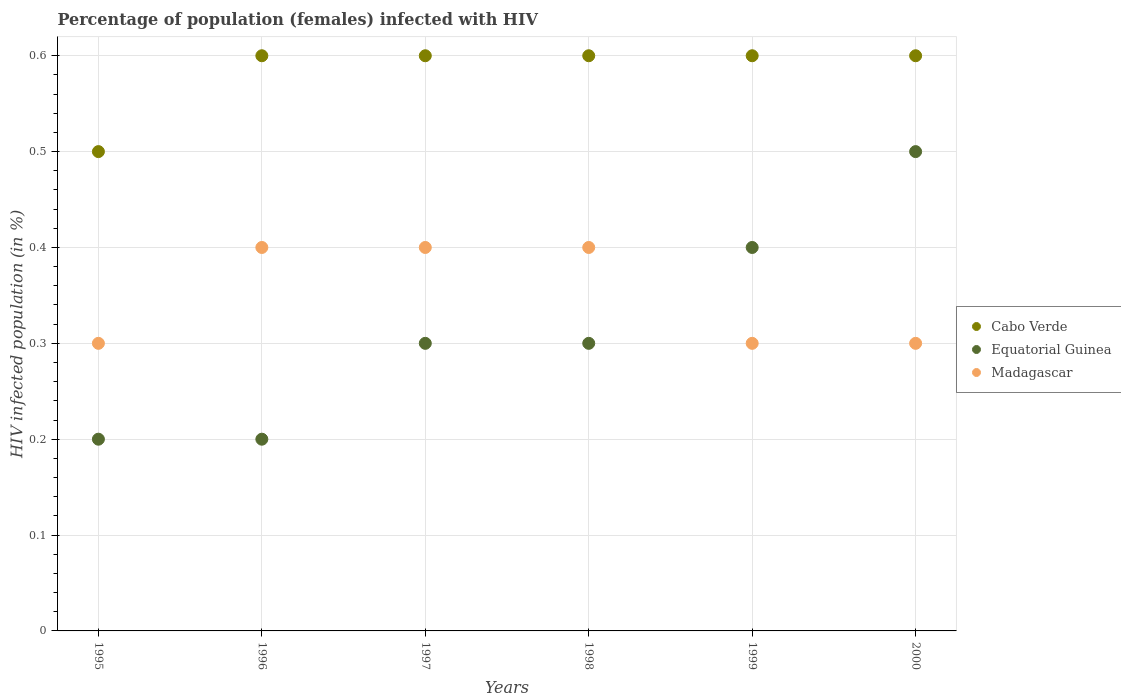Is the number of dotlines equal to the number of legend labels?
Offer a terse response. Yes. Across all years, what is the maximum percentage of HIV infected female population in Madagascar?
Give a very brief answer. 0.4. Across all years, what is the minimum percentage of HIV infected female population in Cabo Verde?
Keep it short and to the point. 0.5. In which year was the percentage of HIV infected female population in Cabo Verde maximum?
Provide a succinct answer. 1996. What is the total percentage of HIV infected female population in Cabo Verde in the graph?
Ensure brevity in your answer.  3.5. What is the difference between the percentage of HIV infected female population in Cabo Verde in 1995 and the percentage of HIV infected female population in Equatorial Guinea in 2000?
Make the answer very short. 0. What is the average percentage of HIV infected female population in Cabo Verde per year?
Ensure brevity in your answer.  0.58. In how many years, is the percentage of HIV infected female population in Madagascar greater than 0.30000000000000004 %?
Keep it short and to the point. 3. What is the ratio of the percentage of HIV infected female population in Equatorial Guinea in 1997 to that in 1999?
Give a very brief answer. 0.75. Is the percentage of HIV infected female population in Cabo Verde in 1997 less than that in 1999?
Your answer should be compact. No. Is the difference between the percentage of HIV infected female population in Cabo Verde in 1995 and 1996 greater than the difference between the percentage of HIV infected female population in Equatorial Guinea in 1995 and 1996?
Make the answer very short. No. What is the difference between the highest and the second highest percentage of HIV infected female population in Equatorial Guinea?
Keep it short and to the point. 0.1. What is the difference between the highest and the lowest percentage of HIV infected female population in Madagascar?
Your response must be concise. 0.1. In how many years, is the percentage of HIV infected female population in Equatorial Guinea greater than the average percentage of HIV infected female population in Equatorial Guinea taken over all years?
Make the answer very short. 2. Does the percentage of HIV infected female population in Equatorial Guinea monotonically increase over the years?
Keep it short and to the point. No. Is the percentage of HIV infected female population in Madagascar strictly greater than the percentage of HIV infected female population in Cabo Verde over the years?
Your answer should be compact. No. How many dotlines are there?
Your answer should be compact. 3. Are the values on the major ticks of Y-axis written in scientific E-notation?
Offer a very short reply. No. Does the graph contain any zero values?
Your answer should be compact. No. Does the graph contain grids?
Offer a very short reply. Yes. Where does the legend appear in the graph?
Your answer should be compact. Center right. How are the legend labels stacked?
Provide a short and direct response. Vertical. What is the title of the graph?
Offer a terse response. Percentage of population (females) infected with HIV. What is the label or title of the Y-axis?
Give a very brief answer. HIV infected population (in %). What is the HIV infected population (in %) of Madagascar in 1996?
Ensure brevity in your answer.  0.4. What is the HIV infected population (in %) in Equatorial Guinea in 1997?
Give a very brief answer. 0.3. What is the HIV infected population (in %) of Madagascar in 1997?
Provide a succinct answer. 0.4. What is the HIV infected population (in %) of Equatorial Guinea in 1998?
Offer a very short reply. 0.3. What is the HIV infected population (in %) of Cabo Verde in 2000?
Make the answer very short. 0.6. What is the HIV infected population (in %) in Equatorial Guinea in 2000?
Provide a succinct answer. 0.5. Across all years, what is the maximum HIV infected population (in %) of Cabo Verde?
Your answer should be compact. 0.6. Across all years, what is the minimum HIV infected population (in %) of Cabo Verde?
Offer a terse response. 0.5. Across all years, what is the minimum HIV infected population (in %) in Equatorial Guinea?
Offer a terse response. 0.2. Across all years, what is the minimum HIV infected population (in %) of Madagascar?
Offer a terse response. 0.3. What is the total HIV infected population (in %) of Equatorial Guinea in the graph?
Make the answer very short. 1.9. What is the difference between the HIV infected population (in %) of Cabo Verde in 1995 and that in 1996?
Offer a terse response. -0.1. What is the difference between the HIV infected population (in %) of Madagascar in 1995 and that in 1997?
Keep it short and to the point. -0.1. What is the difference between the HIV infected population (in %) of Equatorial Guinea in 1995 and that in 1998?
Your answer should be compact. -0.1. What is the difference between the HIV infected population (in %) of Cabo Verde in 1995 and that in 1999?
Give a very brief answer. -0.1. What is the difference between the HIV infected population (in %) of Equatorial Guinea in 1995 and that in 1999?
Offer a very short reply. -0.2. What is the difference between the HIV infected population (in %) of Cabo Verde in 1995 and that in 2000?
Your response must be concise. -0.1. What is the difference between the HIV infected population (in %) in Madagascar in 1996 and that in 1997?
Make the answer very short. 0. What is the difference between the HIV infected population (in %) of Madagascar in 1996 and that in 1998?
Provide a short and direct response. 0. What is the difference between the HIV infected population (in %) in Cabo Verde in 1996 and that in 1999?
Give a very brief answer. 0. What is the difference between the HIV infected population (in %) of Cabo Verde in 1996 and that in 2000?
Give a very brief answer. 0. What is the difference between the HIV infected population (in %) of Equatorial Guinea in 1996 and that in 2000?
Offer a very short reply. -0.3. What is the difference between the HIV infected population (in %) of Cabo Verde in 1997 and that in 1999?
Provide a succinct answer. 0. What is the difference between the HIV infected population (in %) in Madagascar in 1997 and that in 1999?
Ensure brevity in your answer.  0.1. What is the difference between the HIV infected population (in %) in Cabo Verde in 1997 and that in 2000?
Offer a very short reply. 0. What is the difference between the HIV infected population (in %) in Madagascar in 1997 and that in 2000?
Make the answer very short. 0.1. What is the difference between the HIV infected population (in %) in Equatorial Guinea in 1998 and that in 1999?
Provide a succinct answer. -0.1. What is the difference between the HIV infected population (in %) of Madagascar in 1998 and that in 1999?
Make the answer very short. 0.1. What is the difference between the HIV infected population (in %) of Madagascar in 1998 and that in 2000?
Provide a short and direct response. 0.1. What is the difference between the HIV infected population (in %) in Cabo Verde in 1999 and that in 2000?
Offer a terse response. 0. What is the difference between the HIV infected population (in %) in Cabo Verde in 1995 and the HIV infected population (in %) in Madagascar in 1997?
Provide a succinct answer. 0.1. What is the difference between the HIV infected population (in %) in Equatorial Guinea in 1995 and the HIV infected population (in %) in Madagascar in 1997?
Your answer should be compact. -0.2. What is the difference between the HIV infected population (in %) in Cabo Verde in 1995 and the HIV infected population (in %) in Equatorial Guinea in 1998?
Offer a very short reply. 0.2. What is the difference between the HIV infected population (in %) in Cabo Verde in 1995 and the HIV infected population (in %) in Madagascar in 1998?
Make the answer very short. 0.1. What is the difference between the HIV infected population (in %) of Equatorial Guinea in 1995 and the HIV infected population (in %) of Madagascar in 1998?
Your answer should be very brief. -0.2. What is the difference between the HIV infected population (in %) of Equatorial Guinea in 1995 and the HIV infected population (in %) of Madagascar in 1999?
Offer a very short reply. -0.1. What is the difference between the HIV infected population (in %) of Cabo Verde in 1996 and the HIV infected population (in %) of Madagascar in 1997?
Ensure brevity in your answer.  0.2. What is the difference between the HIV infected population (in %) in Equatorial Guinea in 1996 and the HIV infected population (in %) in Madagascar in 1997?
Provide a short and direct response. -0.2. What is the difference between the HIV infected population (in %) of Cabo Verde in 1996 and the HIV infected population (in %) of Equatorial Guinea in 1998?
Give a very brief answer. 0.3. What is the difference between the HIV infected population (in %) in Cabo Verde in 1996 and the HIV infected population (in %) in Madagascar in 1998?
Provide a short and direct response. 0.2. What is the difference between the HIV infected population (in %) of Equatorial Guinea in 1996 and the HIV infected population (in %) of Madagascar in 1998?
Offer a terse response. -0.2. What is the difference between the HIV infected population (in %) of Cabo Verde in 1996 and the HIV infected population (in %) of Equatorial Guinea in 1999?
Provide a succinct answer. 0.2. What is the difference between the HIV infected population (in %) in Equatorial Guinea in 1996 and the HIV infected population (in %) in Madagascar in 1999?
Offer a terse response. -0.1. What is the difference between the HIV infected population (in %) in Equatorial Guinea in 1996 and the HIV infected population (in %) in Madagascar in 2000?
Offer a very short reply. -0.1. What is the difference between the HIV infected population (in %) in Cabo Verde in 1997 and the HIV infected population (in %) in Equatorial Guinea in 1999?
Keep it short and to the point. 0.2. What is the difference between the HIV infected population (in %) of Equatorial Guinea in 1997 and the HIV infected population (in %) of Madagascar in 1999?
Ensure brevity in your answer.  0. What is the difference between the HIV infected population (in %) of Equatorial Guinea in 1997 and the HIV infected population (in %) of Madagascar in 2000?
Your answer should be very brief. 0. What is the difference between the HIV infected population (in %) of Cabo Verde in 1998 and the HIV infected population (in %) of Equatorial Guinea in 1999?
Keep it short and to the point. 0.2. What is the difference between the HIV infected population (in %) in Cabo Verde in 1998 and the HIV infected population (in %) in Madagascar in 1999?
Give a very brief answer. 0.3. What is the difference between the HIV infected population (in %) in Cabo Verde in 1999 and the HIV infected population (in %) in Equatorial Guinea in 2000?
Your answer should be very brief. 0.1. What is the difference between the HIV infected population (in %) of Equatorial Guinea in 1999 and the HIV infected population (in %) of Madagascar in 2000?
Offer a very short reply. 0.1. What is the average HIV infected population (in %) in Cabo Verde per year?
Your answer should be compact. 0.58. What is the average HIV infected population (in %) in Equatorial Guinea per year?
Keep it short and to the point. 0.32. In the year 1995, what is the difference between the HIV infected population (in %) in Equatorial Guinea and HIV infected population (in %) in Madagascar?
Offer a very short reply. -0.1. In the year 1996, what is the difference between the HIV infected population (in %) in Cabo Verde and HIV infected population (in %) in Equatorial Guinea?
Your answer should be compact. 0.4. In the year 1996, what is the difference between the HIV infected population (in %) in Cabo Verde and HIV infected population (in %) in Madagascar?
Provide a short and direct response. 0.2. In the year 1997, what is the difference between the HIV infected population (in %) of Cabo Verde and HIV infected population (in %) of Equatorial Guinea?
Offer a very short reply. 0.3. In the year 1997, what is the difference between the HIV infected population (in %) of Equatorial Guinea and HIV infected population (in %) of Madagascar?
Keep it short and to the point. -0.1. In the year 1998, what is the difference between the HIV infected population (in %) in Equatorial Guinea and HIV infected population (in %) in Madagascar?
Make the answer very short. -0.1. In the year 1999, what is the difference between the HIV infected population (in %) of Cabo Verde and HIV infected population (in %) of Equatorial Guinea?
Keep it short and to the point. 0.2. In the year 1999, what is the difference between the HIV infected population (in %) of Cabo Verde and HIV infected population (in %) of Madagascar?
Your answer should be very brief. 0.3. In the year 1999, what is the difference between the HIV infected population (in %) of Equatorial Guinea and HIV infected population (in %) of Madagascar?
Keep it short and to the point. 0.1. What is the ratio of the HIV infected population (in %) in Equatorial Guinea in 1995 to that in 1997?
Your response must be concise. 0.67. What is the ratio of the HIV infected population (in %) in Madagascar in 1995 to that in 1999?
Provide a succinct answer. 1. What is the ratio of the HIV infected population (in %) in Equatorial Guinea in 1995 to that in 2000?
Offer a very short reply. 0.4. What is the ratio of the HIV infected population (in %) in Equatorial Guinea in 1996 to that in 1997?
Keep it short and to the point. 0.67. What is the ratio of the HIV infected population (in %) in Cabo Verde in 1996 to that in 1998?
Make the answer very short. 1. What is the ratio of the HIV infected population (in %) of Cabo Verde in 1996 to that in 1999?
Give a very brief answer. 1. What is the ratio of the HIV infected population (in %) of Cabo Verde in 1996 to that in 2000?
Ensure brevity in your answer.  1. What is the ratio of the HIV infected population (in %) of Madagascar in 1996 to that in 2000?
Offer a terse response. 1.33. What is the ratio of the HIV infected population (in %) of Cabo Verde in 1997 to that in 1998?
Keep it short and to the point. 1. What is the ratio of the HIV infected population (in %) in Equatorial Guinea in 1997 to that in 1999?
Ensure brevity in your answer.  0.75. What is the ratio of the HIV infected population (in %) of Madagascar in 1997 to that in 1999?
Give a very brief answer. 1.33. What is the ratio of the HIV infected population (in %) in Equatorial Guinea in 1997 to that in 2000?
Your response must be concise. 0.6. What is the ratio of the HIV infected population (in %) of Madagascar in 1997 to that in 2000?
Ensure brevity in your answer.  1.33. What is the ratio of the HIV infected population (in %) of Cabo Verde in 1998 to that in 1999?
Your answer should be compact. 1. What is the ratio of the HIV infected population (in %) in Equatorial Guinea in 1998 to that in 1999?
Your answer should be compact. 0.75. What is the ratio of the HIV infected population (in %) of Equatorial Guinea in 1998 to that in 2000?
Keep it short and to the point. 0.6. What is the ratio of the HIV infected population (in %) in Madagascar in 1998 to that in 2000?
Offer a very short reply. 1.33. What is the ratio of the HIV infected population (in %) in Cabo Verde in 1999 to that in 2000?
Make the answer very short. 1. What is the ratio of the HIV infected population (in %) of Madagascar in 1999 to that in 2000?
Offer a terse response. 1. What is the difference between the highest and the second highest HIV infected population (in %) of Cabo Verde?
Your answer should be compact. 0. What is the difference between the highest and the second highest HIV infected population (in %) of Madagascar?
Your answer should be very brief. 0. What is the difference between the highest and the lowest HIV infected population (in %) of Madagascar?
Your response must be concise. 0.1. 